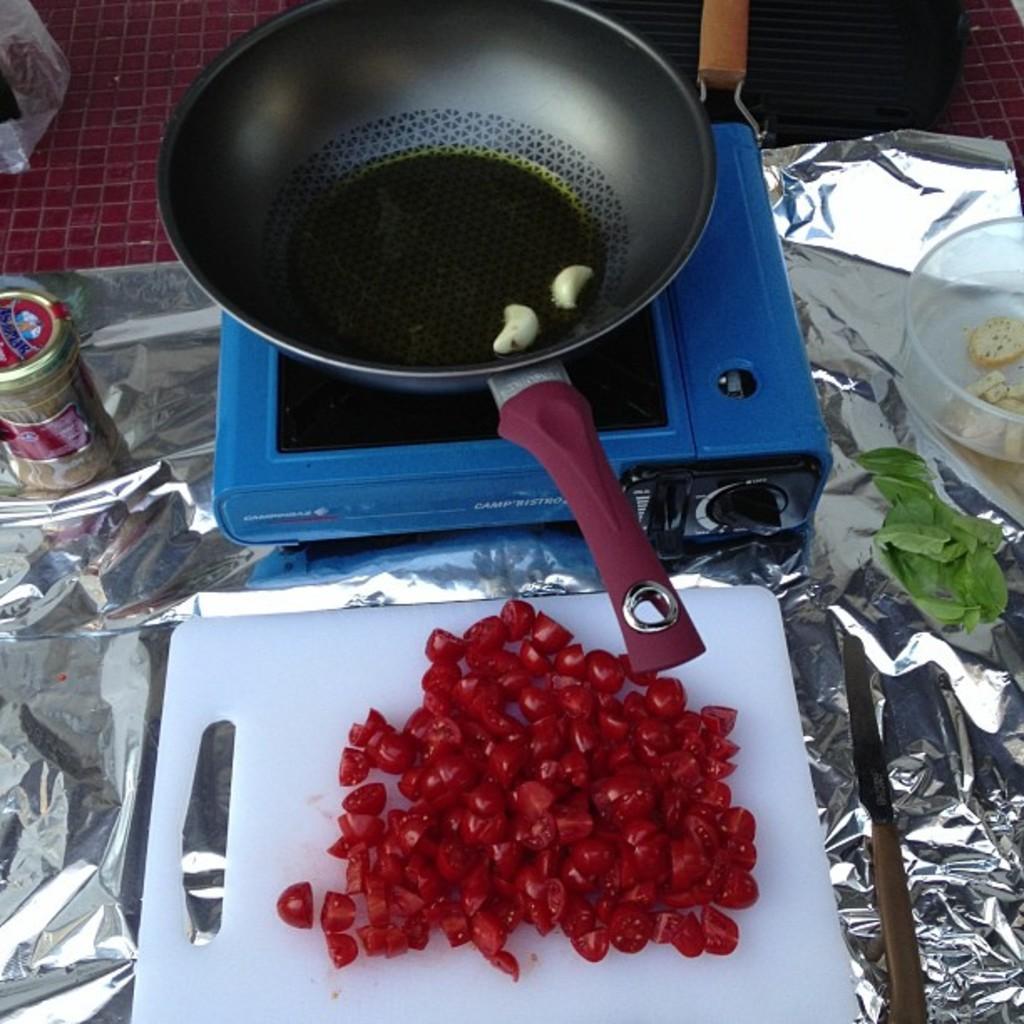In one or two sentences, can you explain what this image depicts? Here in this picture we can see a table, on which we can see a chopping board with some chilies chopped and in front of that we can see a stove with a pan present on it and we can also see other leaves and boxes present beside it. 